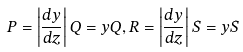Convert formula to latex. <formula><loc_0><loc_0><loc_500><loc_500>P = \left | \frac { d y } { d z } \right | Q = y Q , R = \left | \frac { d y } { d z } \right | S = y S</formula> 